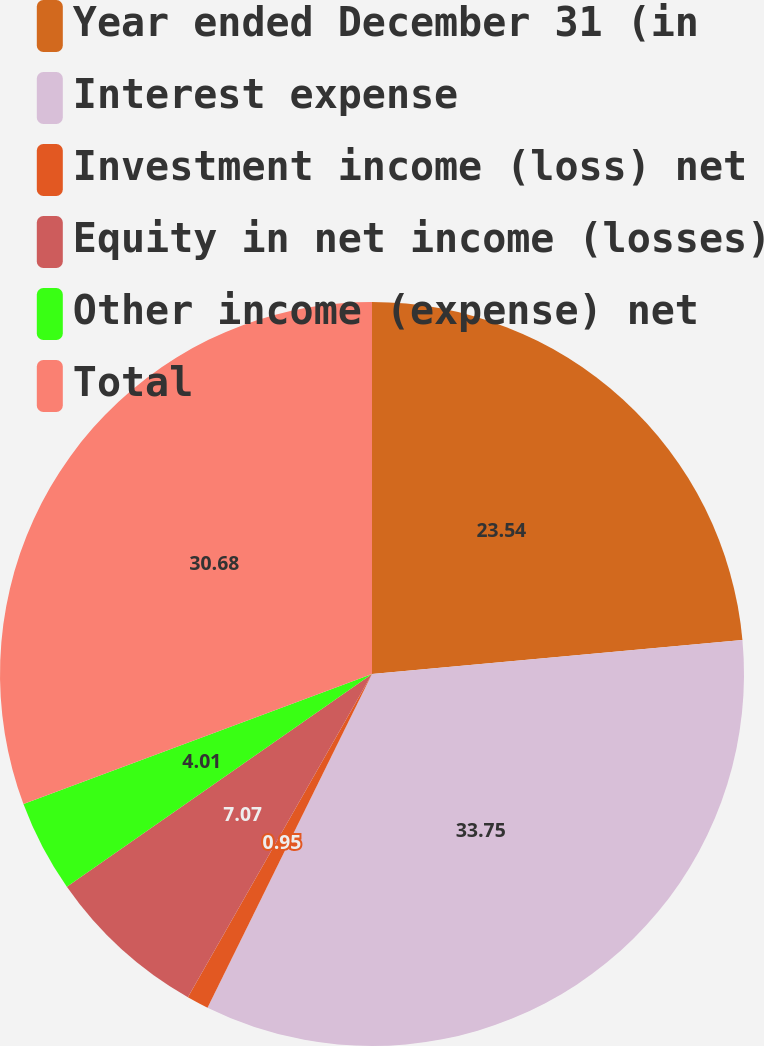Convert chart. <chart><loc_0><loc_0><loc_500><loc_500><pie_chart><fcel>Year ended December 31 (in<fcel>Interest expense<fcel>Investment income (loss) net<fcel>Equity in net income (losses)<fcel>Other income (expense) net<fcel>Total<nl><fcel>23.54%<fcel>33.75%<fcel>0.95%<fcel>7.07%<fcel>4.01%<fcel>30.68%<nl></chart> 